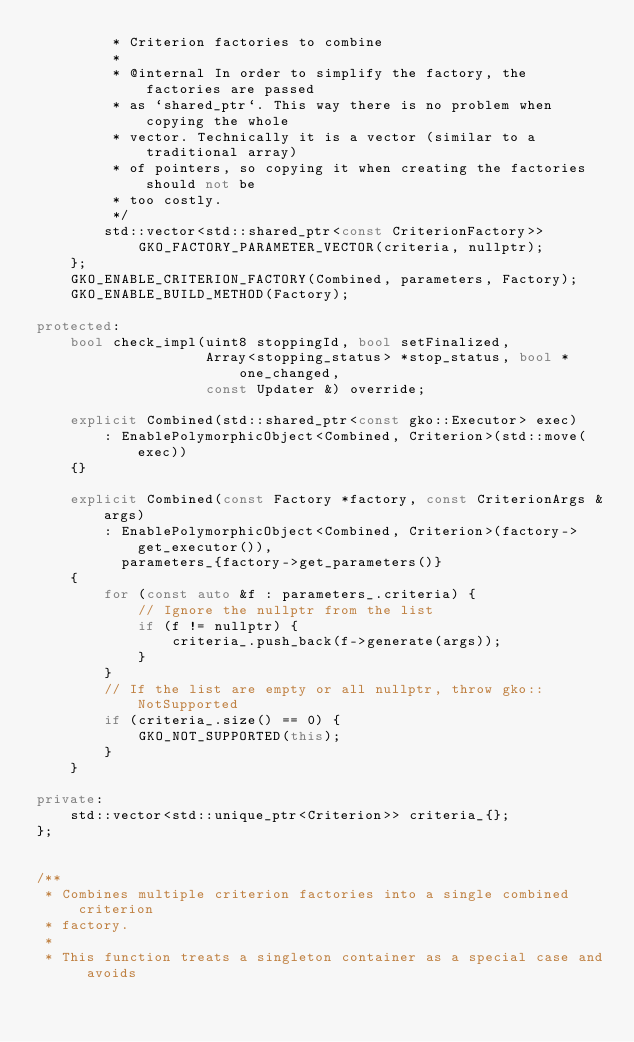Convert code to text. <code><loc_0><loc_0><loc_500><loc_500><_C++_>         * Criterion factories to combine
         *
         * @internal In order to simplify the factory, the factories are passed
         * as `shared_ptr`. This way there is no problem when copying the whole
         * vector. Technically it is a vector (similar to a traditional array)
         * of pointers, so copying it when creating the factories should not be
         * too costly.
         */
        std::vector<std::shared_ptr<const CriterionFactory>>
            GKO_FACTORY_PARAMETER_VECTOR(criteria, nullptr);
    };
    GKO_ENABLE_CRITERION_FACTORY(Combined, parameters, Factory);
    GKO_ENABLE_BUILD_METHOD(Factory);

protected:
    bool check_impl(uint8 stoppingId, bool setFinalized,
                    Array<stopping_status> *stop_status, bool *one_changed,
                    const Updater &) override;

    explicit Combined(std::shared_ptr<const gko::Executor> exec)
        : EnablePolymorphicObject<Combined, Criterion>(std::move(exec))
    {}

    explicit Combined(const Factory *factory, const CriterionArgs &args)
        : EnablePolymorphicObject<Combined, Criterion>(factory->get_executor()),
          parameters_{factory->get_parameters()}
    {
        for (const auto &f : parameters_.criteria) {
            // Ignore the nullptr from the list
            if (f != nullptr) {
                criteria_.push_back(f->generate(args));
            }
        }
        // If the list are empty or all nullptr, throw gko::NotSupported
        if (criteria_.size() == 0) {
            GKO_NOT_SUPPORTED(this);
        }
    }

private:
    std::vector<std::unique_ptr<Criterion>> criteria_{};
};


/**
 * Combines multiple criterion factories into a single combined criterion
 * factory.
 *
 * This function treats a singleton container as a special case and avoids</code> 